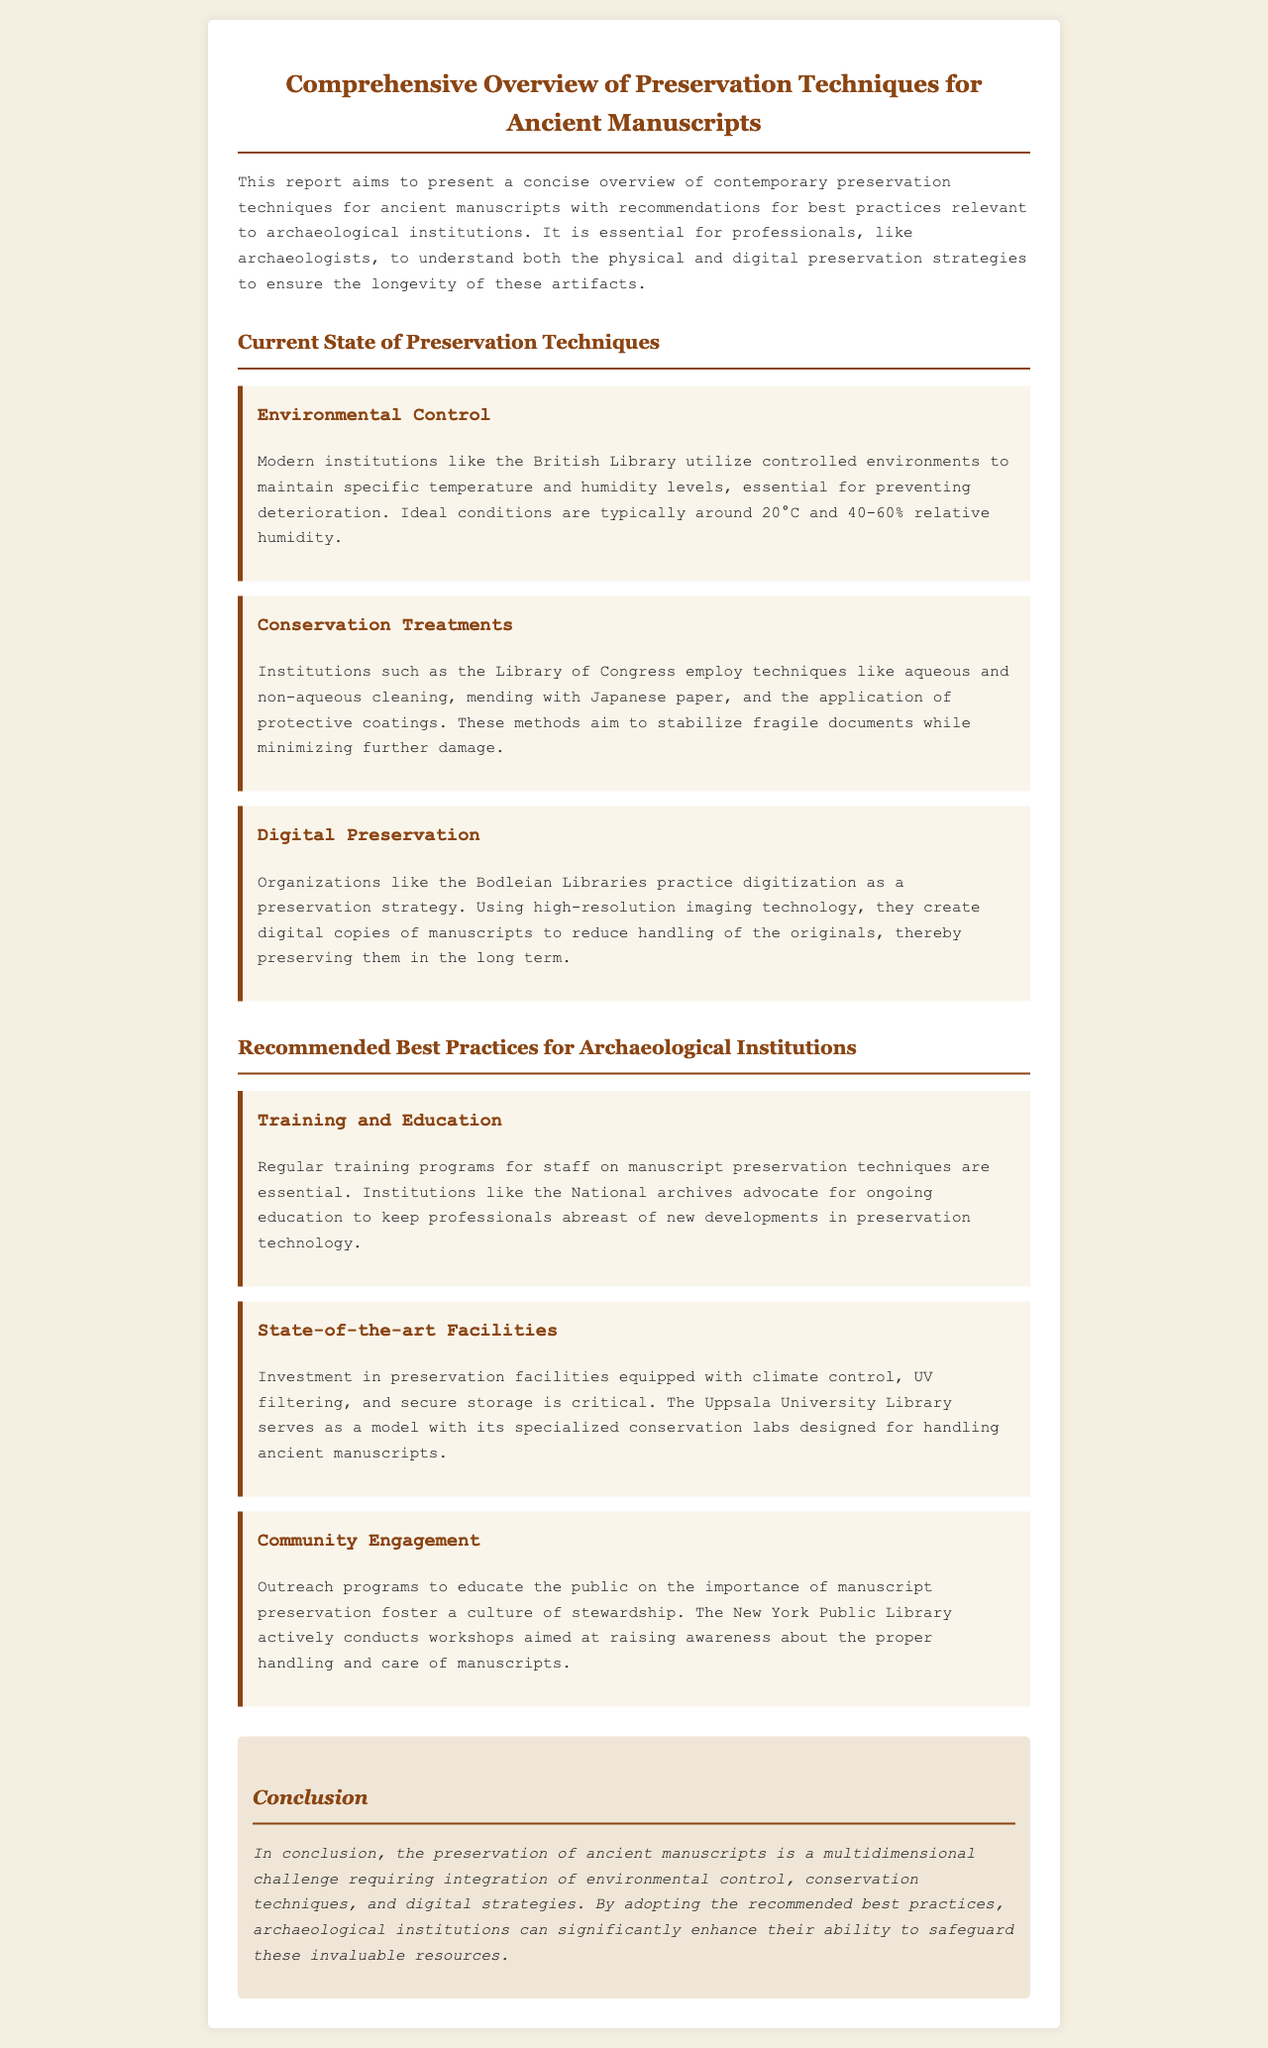What is the title of the report? The title is the main heading of the document that summarizes its content.
Answer: Comprehensive Overview of Preservation Techniques for Ancient Manuscripts What is the ideal temperature for manuscript preservation? The ideal temperature is mentioned in the section on Environmental Control, indicating the conditions necessary for preservation.
Answer: 20°C Which institution uses high-resolution imaging for digitization? The institution mentioned in the Digital Preservation section that practices this technique is noted for its efforts to create digital copies.
Answer: Bodleian Libraries What is a recommended best practice for archaeological institutions related to staff? The recommendation related to staff emphasizes the importance of knowledge and skills in preservation techniques.
Answer: Training and Education What type of control is critical for preservation facilities? This refers to a specific environmental condition that must be maintained in preservation facilities as stated in the best practices.
Answer: Climate control Which library is highlighted as a model for preservation facilities? This is the institution that showcases specialized labs for manuscript handling as per the best practices section.
Answer: Uppsala University Library What is the aim of community engagement programs? The purpose of these programs is derived from their description in the best practices section, focusing on public awareness.
Answer: Stewardship What is the overarching challenge discussed in the conclusion? The conclusion sums up the main issues present in manuscript preservation efforts outlined throughout the report.
Answer: Multidimensional challenge 